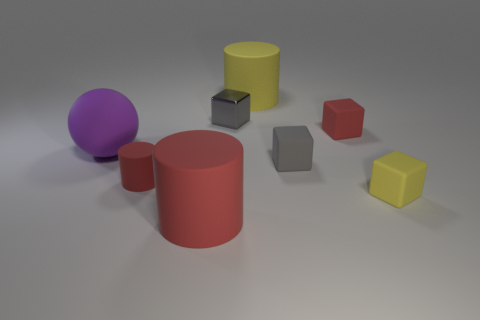Subtract 1 cubes. How many cubes are left? 3 Add 1 large gray objects. How many objects exist? 9 Subtract all cylinders. How many objects are left? 5 Add 6 tiny rubber blocks. How many tiny rubber blocks are left? 9 Add 4 gray metal objects. How many gray metal objects exist? 5 Subtract 1 gray blocks. How many objects are left? 7 Subtract all tiny gray metal spheres. Subtract all big purple rubber spheres. How many objects are left? 7 